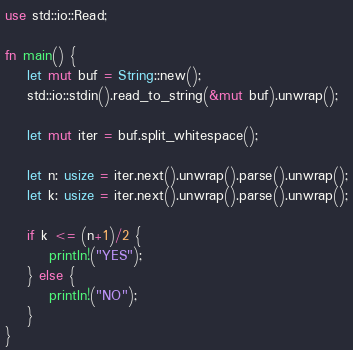<code> <loc_0><loc_0><loc_500><loc_500><_Rust_>use std::io::Read;

fn main() {
    let mut buf = String::new();
    std::io::stdin().read_to_string(&mut buf).unwrap();
    
    let mut iter = buf.split_whitespace();
    
    let n: usize = iter.next().unwrap().parse().unwrap();
    let k: usize = iter.next().unwrap().parse().unwrap();
    
    if k <= (n+1)/2 {
        println!("YES");
    } else {
        println!("NO");
    }
}</code> 